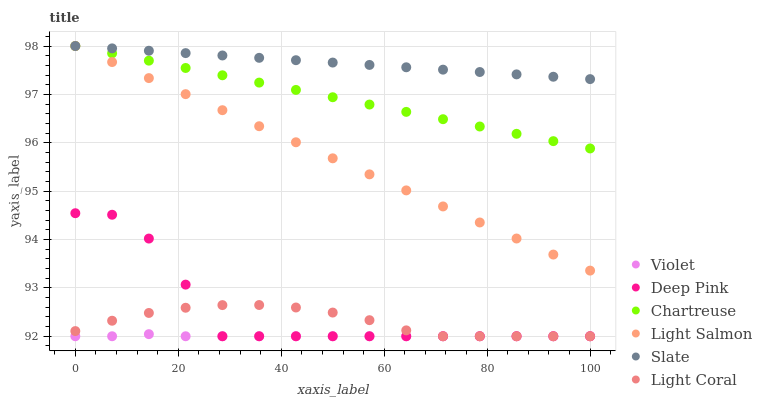Does Violet have the minimum area under the curve?
Answer yes or no. Yes. Does Slate have the maximum area under the curve?
Answer yes or no. Yes. Does Deep Pink have the minimum area under the curve?
Answer yes or no. No. Does Deep Pink have the maximum area under the curve?
Answer yes or no. No. Is Chartreuse the smoothest?
Answer yes or no. Yes. Is Deep Pink the roughest?
Answer yes or no. Yes. Is Slate the smoothest?
Answer yes or no. No. Is Slate the roughest?
Answer yes or no. No. Does Deep Pink have the lowest value?
Answer yes or no. Yes. Does Slate have the lowest value?
Answer yes or no. No. Does Chartreuse have the highest value?
Answer yes or no. Yes. Does Deep Pink have the highest value?
Answer yes or no. No. Is Deep Pink less than Light Salmon?
Answer yes or no. Yes. Is Chartreuse greater than Violet?
Answer yes or no. Yes. Does Light Coral intersect Deep Pink?
Answer yes or no. Yes. Is Light Coral less than Deep Pink?
Answer yes or no. No. Is Light Coral greater than Deep Pink?
Answer yes or no. No. Does Deep Pink intersect Light Salmon?
Answer yes or no. No. 